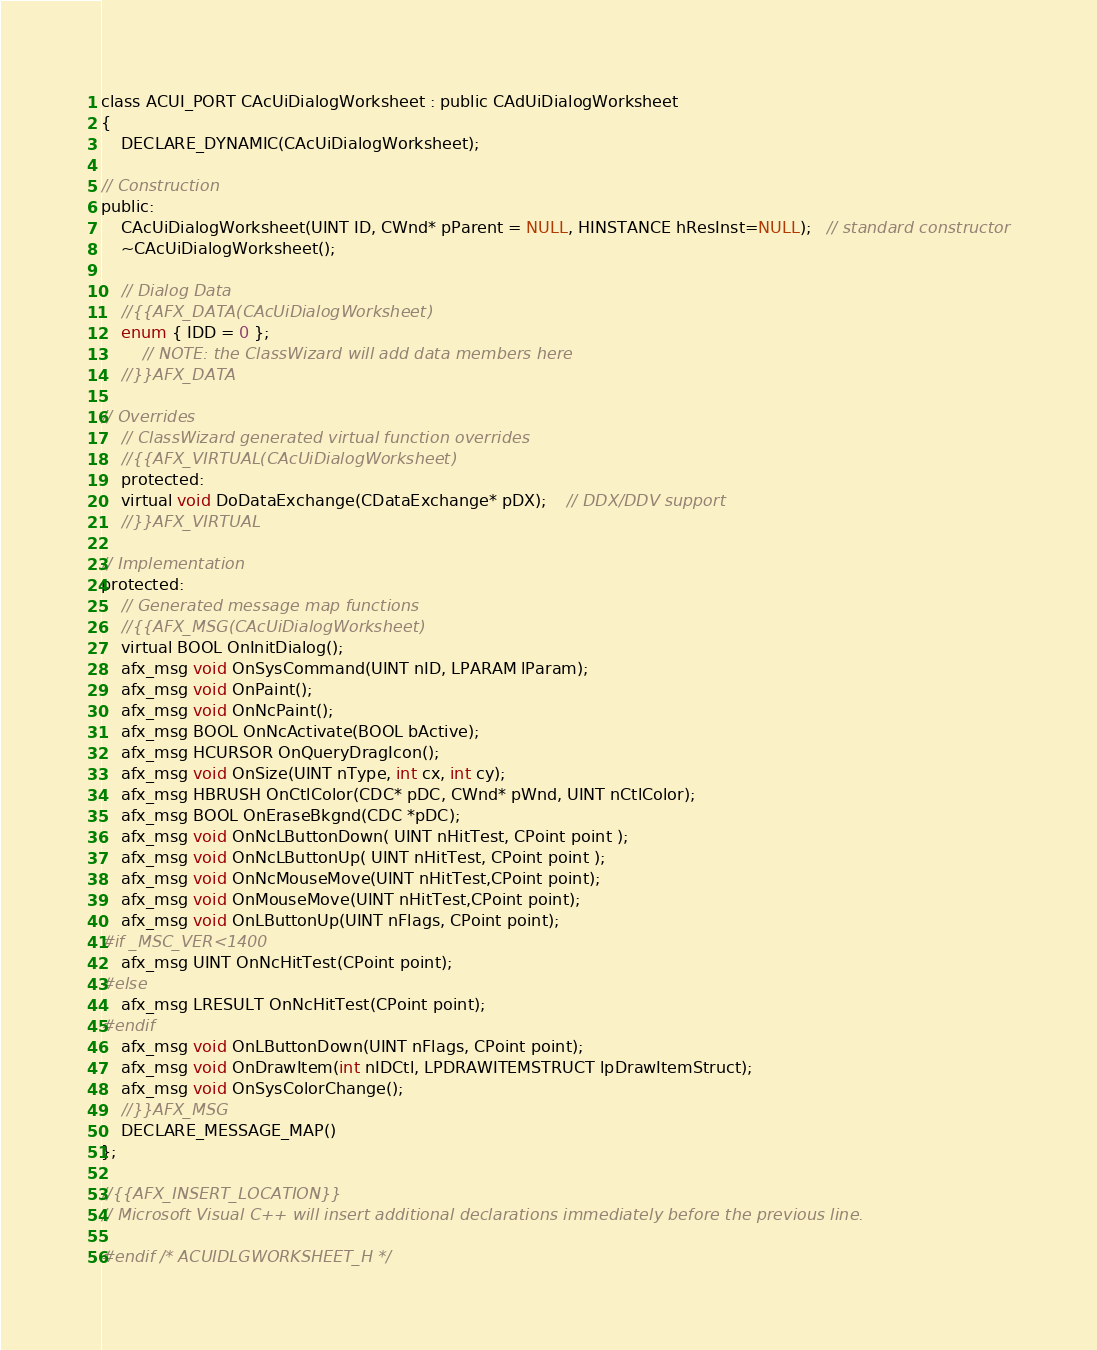<code> <loc_0><loc_0><loc_500><loc_500><_C_>
class ACUI_PORT CAcUiDialogWorksheet : public CAdUiDialogWorksheet
{
    DECLARE_DYNAMIC(CAcUiDialogWorksheet);
    
// Construction
public:
    CAcUiDialogWorksheet(UINT ID, CWnd* pParent = NULL, HINSTANCE hResInst=NULL);   // standard constructor
    ~CAcUiDialogWorksheet();

    // Dialog Data
    //{{AFX_DATA(CAcUiDialogWorksheet)
    enum { IDD = 0 };
        // NOTE: the ClassWizard will add data members here
    //}}AFX_DATA

// Overrides
    // ClassWizard generated virtual function overrides
    //{{AFX_VIRTUAL(CAcUiDialogWorksheet)
    protected:
    virtual void DoDataExchange(CDataExchange* pDX);    // DDX/DDV support
    //}}AFX_VIRTUAL

// Implementation
protected:
    // Generated message map functions
    //{{AFX_MSG(CAcUiDialogWorksheet)
    virtual BOOL OnInitDialog();
    afx_msg void OnSysCommand(UINT nID, LPARAM lParam);
    afx_msg void OnPaint();
    afx_msg void OnNcPaint();
    afx_msg BOOL OnNcActivate(BOOL bActive);
    afx_msg HCURSOR OnQueryDragIcon();
    afx_msg void OnSize(UINT nType, int cx, int cy);
    afx_msg HBRUSH OnCtlColor(CDC* pDC, CWnd* pWnd, UINT nCtlColor);
    afx_msg BOOL OnEraseBkgnd(CDC *pDC);
    afx_msg void OnNcLButtonDown( UINT nHitTest, CPoint point );
    afx_msg void OnNcLButtonUp( UINT nHitTest, CPoint point );
    afx_msg void OnNcMouseMove(UINT nHitTest,CPoint point);
    afx_msg void OnMouseMove(UINT nHitTest,CPoint point);
    afx_msg void OnLButtonUp(UINT nFlags, CPoint point);
#if _MSC_VER<1400
    afx_msg UINT OnNcHitTest(CPoint point);
#else
    afx_msg LRESULT OnNcHitTest(CPoint point);
#endif
    afx_msg void OnLButtonDown(UINT nFlags, CPoint point);
    afx_msg void OnDrawItem(int nIDCtl, LPDRAWITEMSTRUCT lpDrawItemStruct);
    afx_msg void OnSysColorChange();
    //}}AFX_MSG
    DECLARE_MESSAGE_MAP()
};

//{{AFX_INSERT_LOCATION}}
// Microsoft Visual C++ will insert additional declarations immediately before the previous line.

#endif /* ACUIDLGWORKSHEET_H */
</code> 